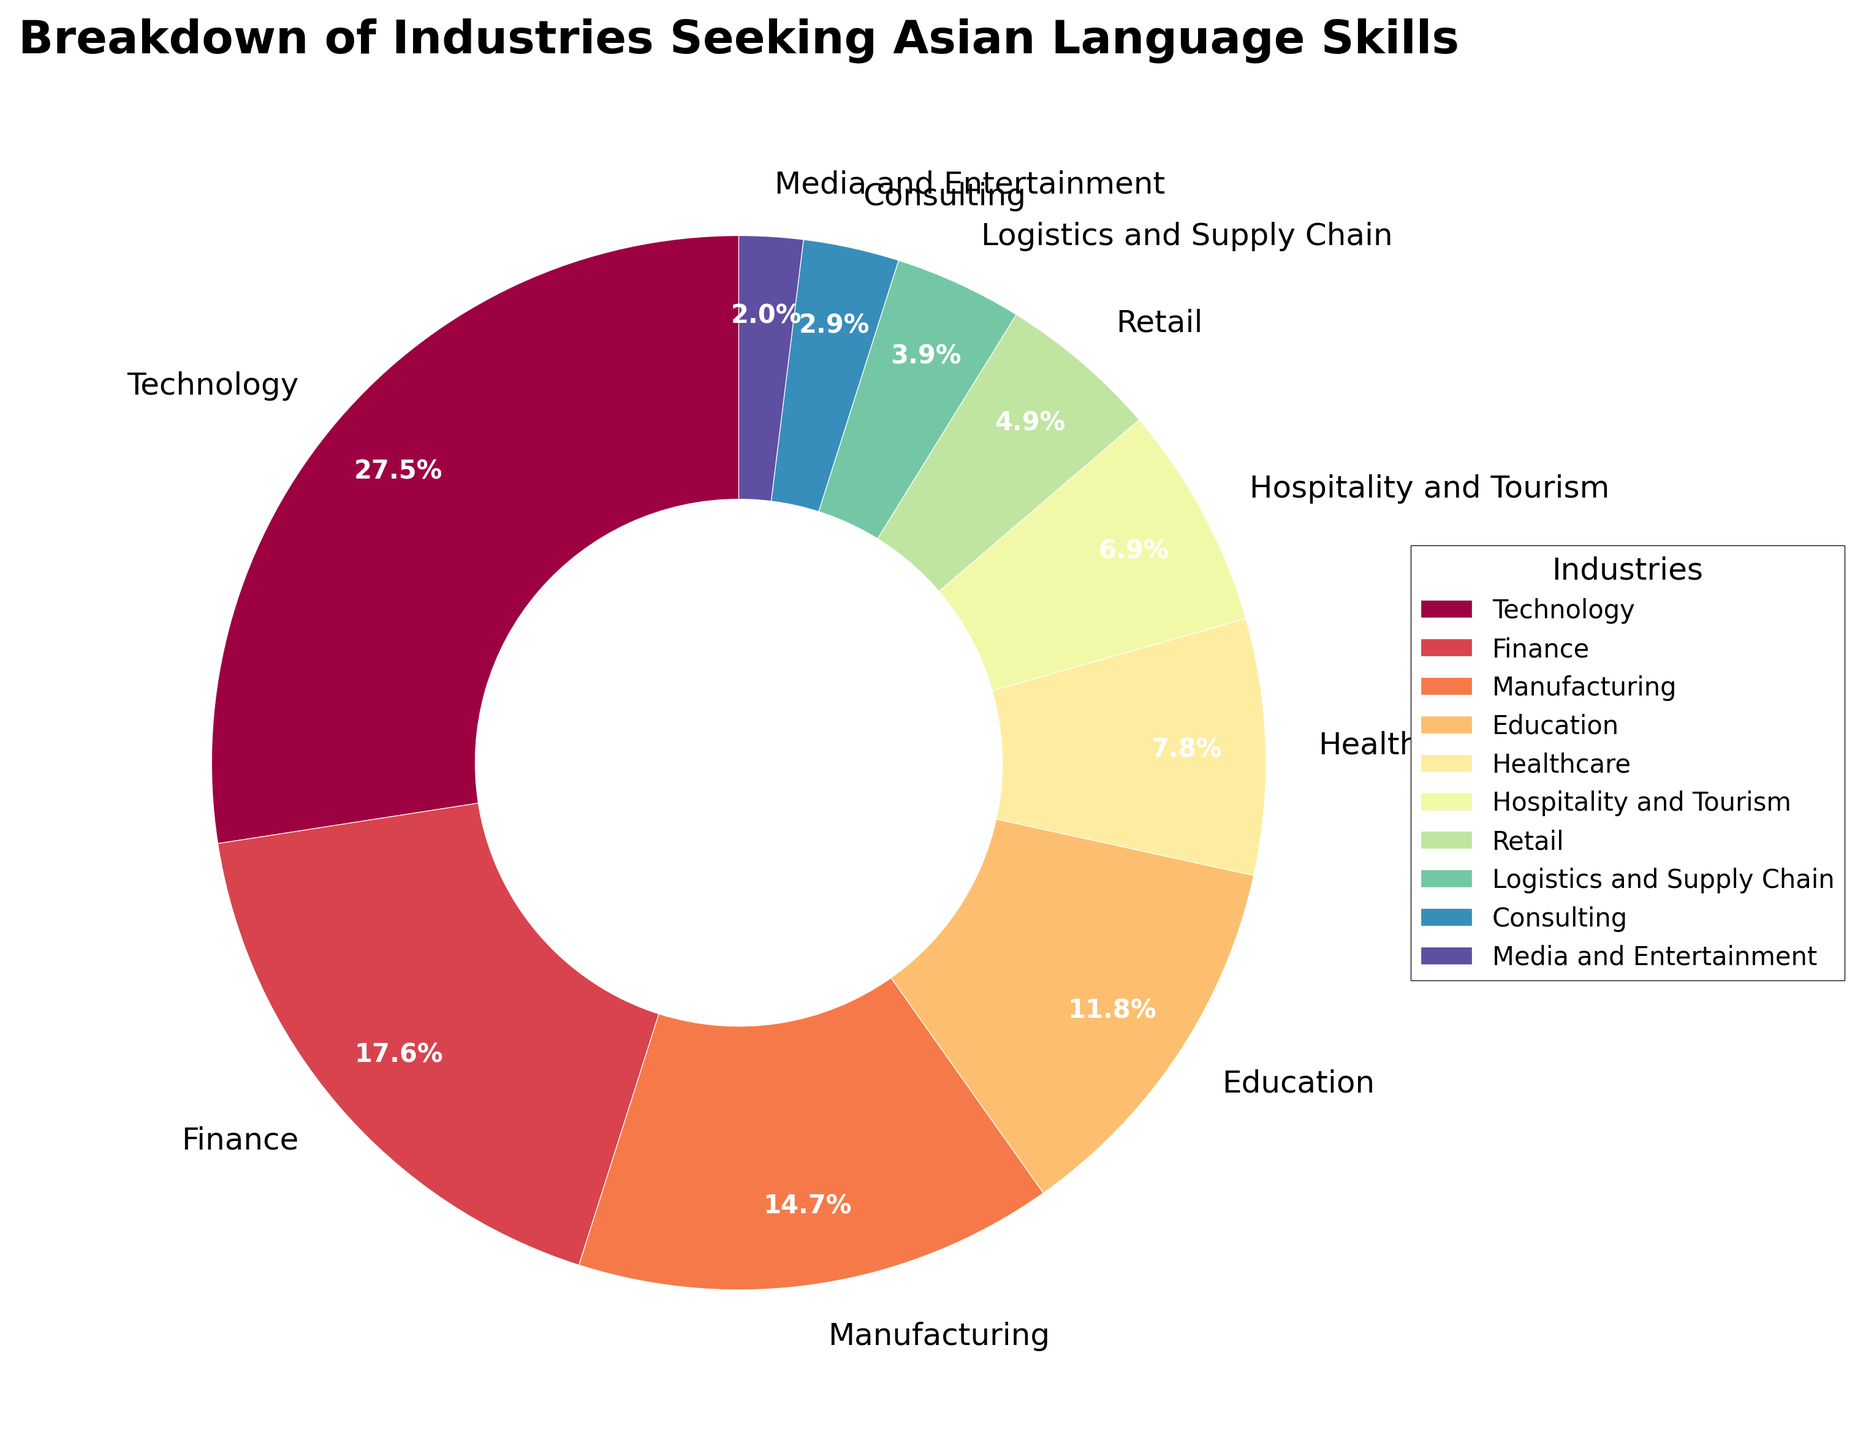What is the industry with the largest percentage of demand for Asian language skills? The pie chart shows various industries along with their respective percentages. The largest section belongs to the Technology sector, which is 28%.
Answer: Technology How much greater is the percentage of demand in the Technology industry compared to the Hospitality and Tourism industry? From the pie chart, the Technology industry has 28% and the Hospitality and Tourism industry has 7%. The difference can be calculated as 28% - 7% = 21%.
Answer: 21% Which industries together make up more than 50% of the total demand? By looking at the pie chart, you can sum the percentages of the top industries: Technology (28%) and Finance (18%). This combined total is 28% + 18% = 46%, which is still less than 50%. Adding Manufacturing (15%) pushes it to 61%, making it more than 50%.
Answer: Technology, Finance, Manufacturing By how much does the percentage of demand in the Education industry exceed that in the Logistics and Supply Chain industry? The pie chart shows Education at 12% and Logistics and Supply Chain at 4%. The difference is calculated as 12% - 4% = 8%.
Answer: 8% What is the combined percentage of demand for the Healthcare and Retail industries? According to the pie chart, Healthcare has 8% and Retail has 5%. The combined percentage is 8% + 5% = 13%.
Answer: 13% Which industry has the least demand for Asian language skills and what is its percentage? The smallest section on the pie chart corresponds to Media and Entertainment, which has a percentage of 2%.
Answer: Media and Entertainment, 2% Are there more industries with less than or equal to 5% demand or more than 5% demand? By observing the pie chart, industries with more than 5% demand are Technology, Finance, Manufacturing, Education, Healthcare, and Hospitality and Tourism (6 categories). Industries with 5% or less are Retail, Logistics and Supply Chain, Consulting, and Media and Entertainment (4 categories).
Answer: More industries with more than 5% demand Add the percentages of the top three industries and subtract the percentage of the lowest industry. What is the result? The top three industries are Technology (28%), Finance (18%), and Manufacturing (15%), adding up to 28% + 18% + 15% = 61%. Subtract the percentage of Media and Entertainment, which is 2%, leading to 61% - 2% = 59%.
Answer: 59% Which industry represents more than half as much demand as the Technology industry, but less than the Finance industry? From the pie chart, the Technology industry's demand is 28%. Half of this is 14%. The Finance industry is at 18%. The Manufacturing sector at 15% fits these conditions because 15% is more than half of 28% and less than 18%.
Answer: Manufacturing 